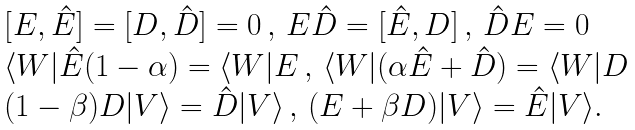Convert formula to latex. <formula><loc_0><loc_0><loc_500><loc_500>\begin{array} { l } [ E , \hat { E } ] = [ D , \hat { D } ] = 0 \, , \, E \hat { D } = [ \hat { E } , D ] \, , \, \hat { D } E = 0 \\ \langle W | \hat { E } ( 1 - \alpha ) = \langle W | E \, , \, \langle W | ( \alpha \hat { E } + \hat { D } ) = \langle W | D \\ ( 1 - \beta ) D | V \rangle = \hat { D } | V \rangle \, , \, ( E + \beta D ) | V \rangle = \hat { E } | V \rangle . \end{array}</formula> 